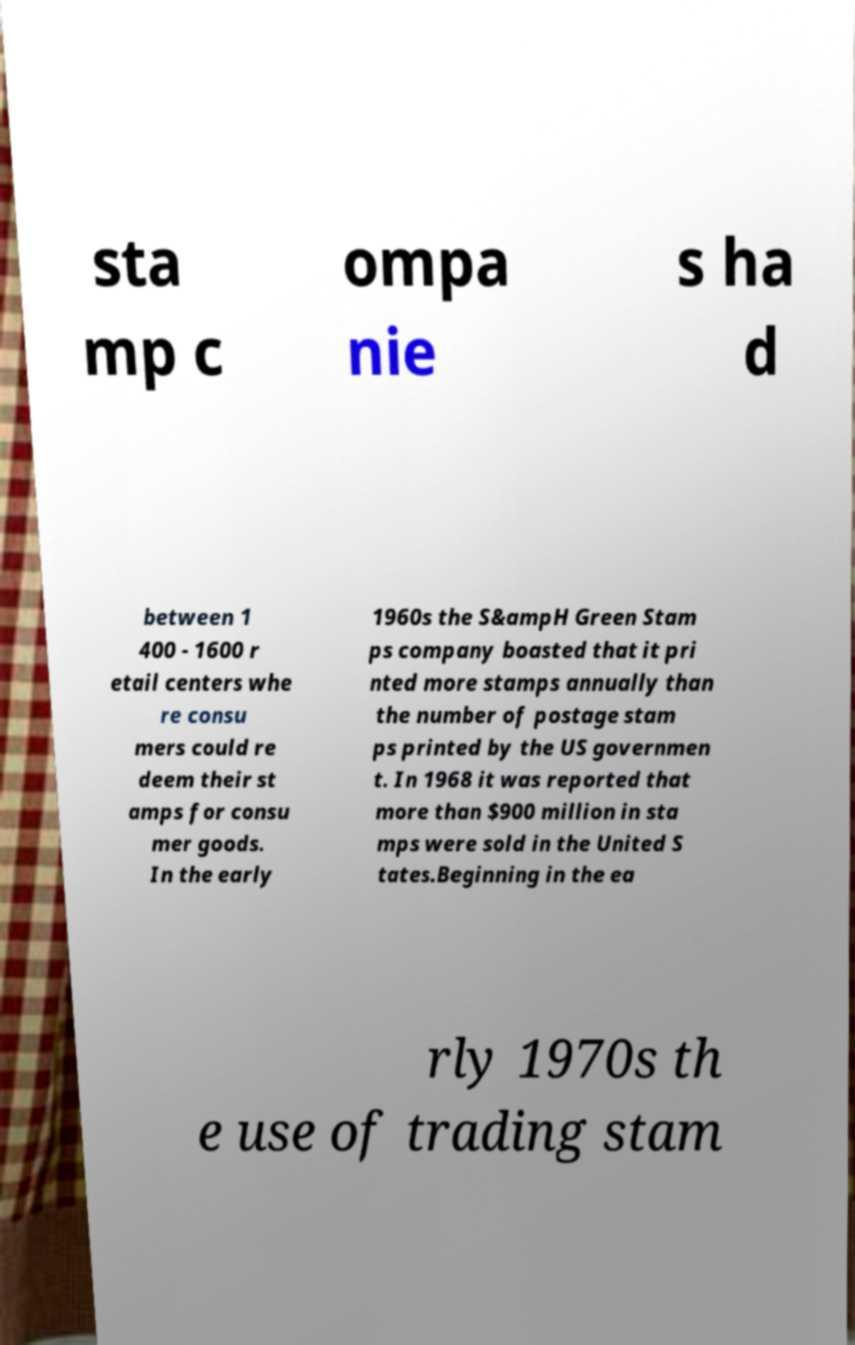Please identify and transcribe the text found in this image. sta mp c ompa nie s ha d between 1 400 - 1600 r etail centers whe re consu mers could re deem their st amps for consu mer goods. In the early 1960s the S&ampH Green Stam ps company boasted that it pri nted more stamps annually than the number of postage stam ps printed by the US governmen t. In 1968 it was reported that more than $900 million in sta mps were sold in the United S tates.Beginning in the ea rly 1970s th e use of trading stam 